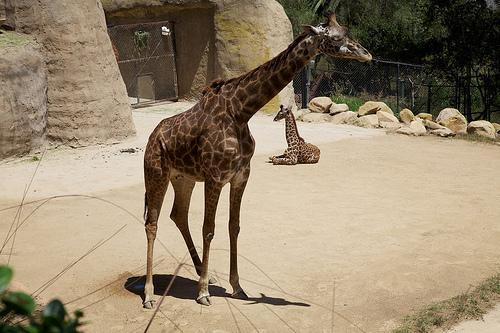Question: what kind of animal is in the photograph?
Choices:
A. Elephant.
B. Dog.
C. Cat.
D. Giraffe.
Answer with the letter. Answer: D Question: where are the giraffes?
Choices:
A. Office.
B. In an enclosure.
C. Bathroom.
D. Ballpark.
Answer with the letter. Answer: B Question: who is in front of the baby giraffe?
Choices:
A. Zoo keeper.
B. Policeman.
C. The adult giraffe.
D. Elephant.
Answer with the letter. Answer: C Question: what are the giraffes standing on?
Choices:
A. Grass.
B. Water.
C. Carpet.
D. Sand.
Answer with the letter. Answer: D Question: how many giraffes are in this photograph?
Choices:
A. Three.
B. Two.
C. One.
D. Six.
Answer with the letter. Answer: B 